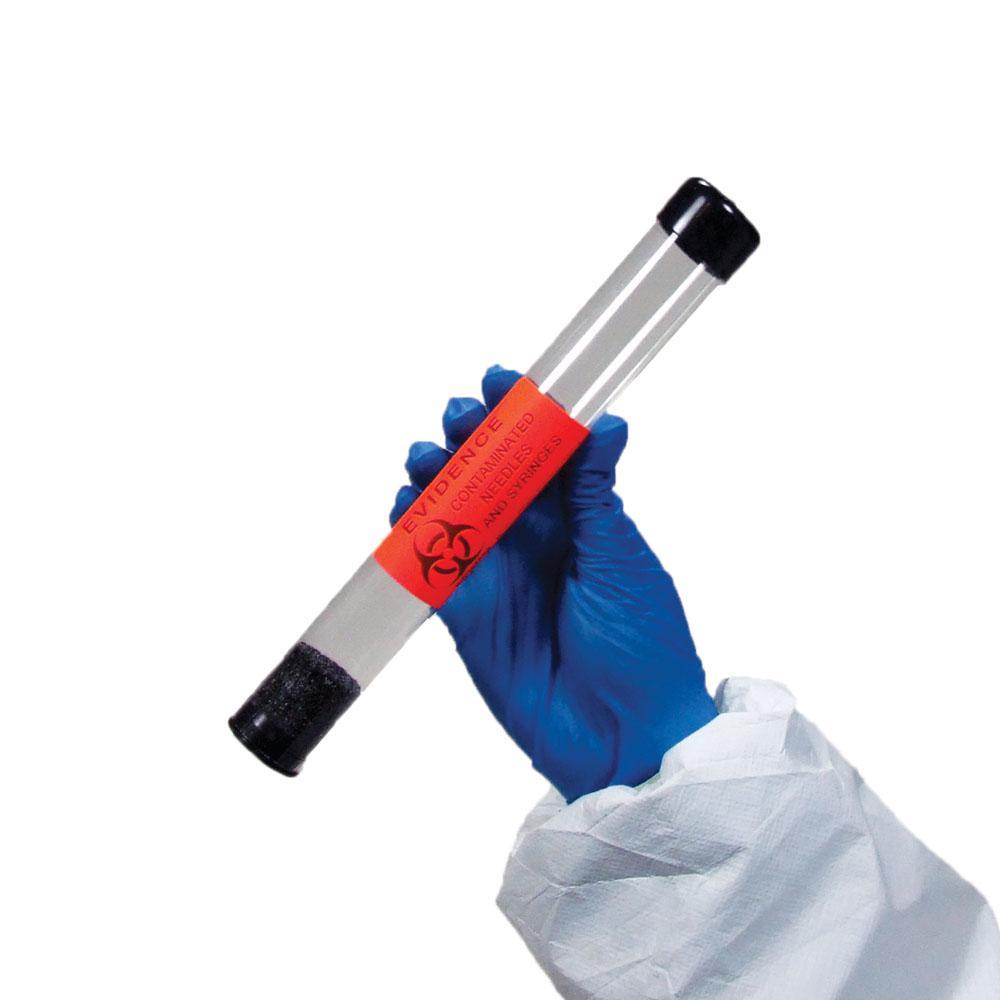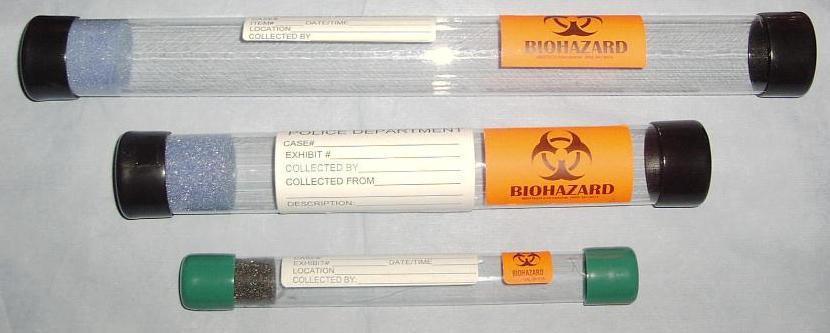The first image is the image on the left, the second image is the image on the right. For the images displayed, is the sentence "There are two canisters in the right image." factually correct? Answer yes or no. No. The first image is the image on the left, the second image is the image on the right. Examine the images to the left and right. Is the description "An image shows at least three tubes with caps on the ends." accurate? Answer yes or no. Yes. 